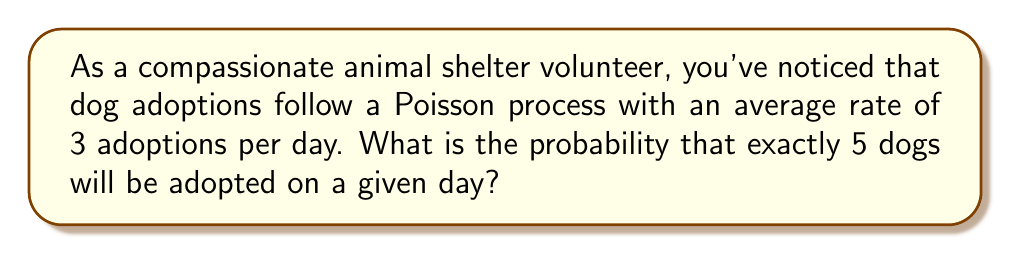Can you solve this math problem? To solve this problem, we'll use the Poisson distribution formula:

$$P(X = k) = \frac{e^{-\lambda} \lambda^k}{k!}$$

Where:
$\lambda$ = average rate of events (adoptions per day)
$k$ = number of events we're interested in
$e$ = Euler's number (approximately 2.71828)

Given:
$\lambda = 3$ adoptions per day
$k = 5$ adoptions

Step 1: Substitute the values into the formula
$$P(X = 5) = \frac{e^{-3} 3^5}{5!}$$

Step 2: Calculate $3^5$
$$3^5 = 243$$

Step 3: Calculate $5!$
$$5! = 5 \times 4 \times 3 \times 2 \times 1 = 120$$

Step 4: Calculate $e^{-3}$
$$e^{-3} \approx 0.0497871$$

Step 5: Put it all together and calculate
$$P(X = 5) = \frac{0.0497871 \times 243}{120} \approx 0.1008$$

Therefore, the probability of exactly 5 dogs being adopted on a given day is approximately 0.1008 or 10.08%.
Answer: 0.1008 